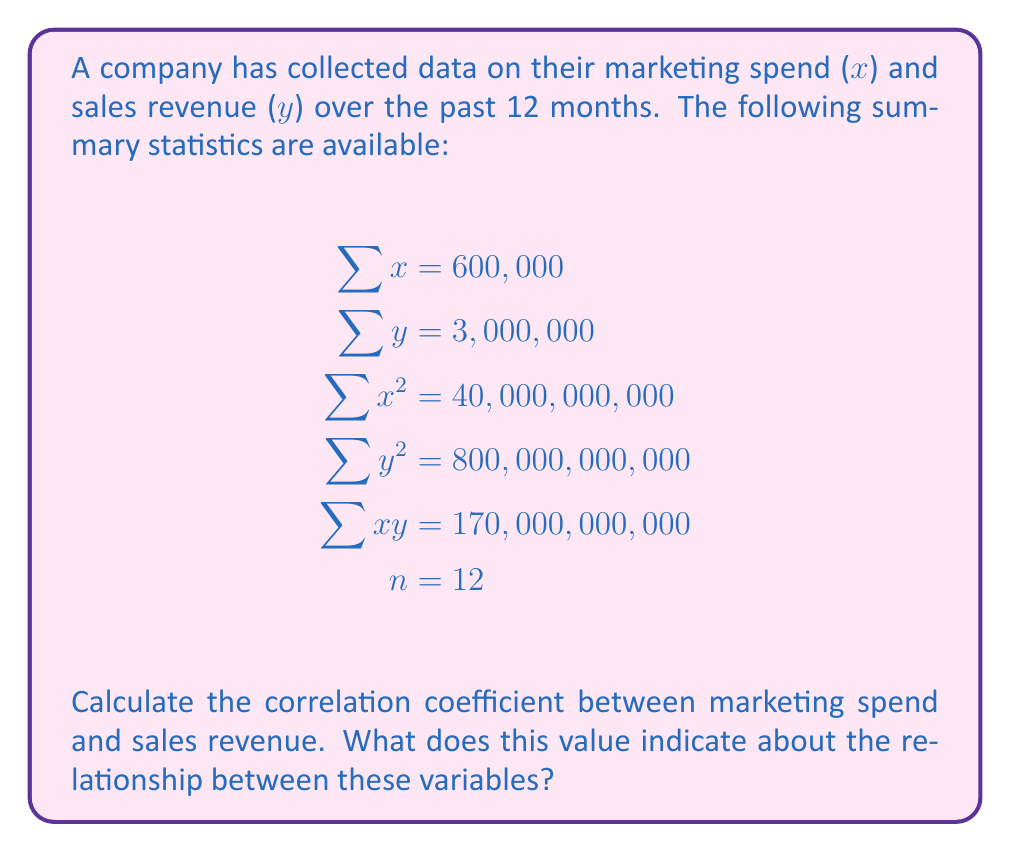Solve this math problem. To calculate the correlation coefficient, we'll use the formula:

$$r = \frac{n\sum xy - \sum x \sum y}{\sqrt{[n\sum x^2 - (\sum x)^2][n\sum y^2 - (\sum y)^2]}}$$

Step 1: Calculate $n\sum xy$
$n\sum xy = 12 \times 170,000,000,000 = 2,040,000,000,000$

Step 2: Calculate $\sum x \sum y$
$\sum x \sum y = 600,000 \times 3,000,000 = 1,800,000,000,000$

Step 3: Calculate $n\sum x^2$
$n\sum x^2 = 12 \times 40,000,000,000 = 480,000,000,000$

Step 4: Calculate $(\sum x)^2$
$(\sum x)^2 = 600,000^2 = 360,000,000,000$

Step 5: Calculate $n\sum y^2$
$n\sum y^2 = 12 \times 800,000,000,000 = 9,600,000,000,000$

Step 6: Calculate $(\sum y)^2$
$(\sum y)^2 = 3,000,000^2 = 9,000,000,000,000$

Step 7: Substitute these values into the correlation coefficient formula

$$r = \frac{2,040,000,000,000 - 1,800,000,000,000}{\sqrt{(480,000,000,000 - 360,000,000,000)(9,600,000,000,000 - 9,000,000,000,000)}}$$

$$r = \frac{240,000,000,000}{\sqrt{(120,000,000,000)(600,000,000,000)}}$$

$$r = \frac{240,000,000,000}{\sqrt{72,000,000,000,000,000,000}}$$

$$r = \frac{240,000,000,000}{268,328,157,299.975} \approx 0.894$$

The correlation coefficient is approximately 0.894, which indicates a strong positive correlation between marketing spend and sales revenue. This suggests that as marketing spend increases, sales revenue tends to increase as well.
Answer: 0.894 (strong positive correlation) 